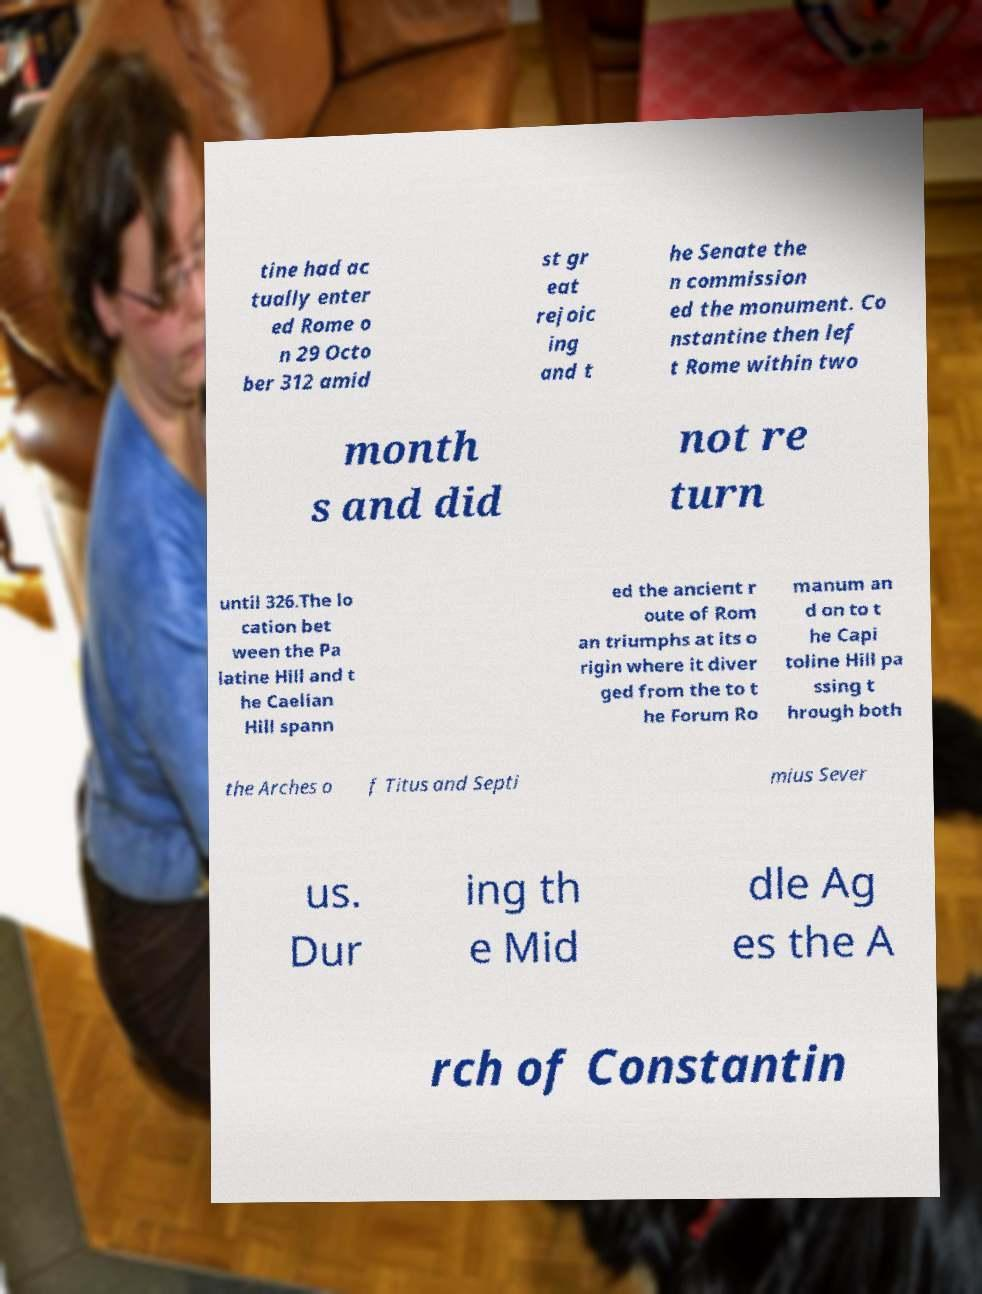Please identify and transcribe the text found in this image. tine had ac tually enter ed Rome o n 29 Octo ber 312 amid st gr eat rejoic ing and t he Senate the n commission ed the monument. Co nstantine then lef t Rome within two month s and did not re turn until 326.The lo cation bet ween the Pa latine Hill and t he Caelian Hill spann ed the ancient r oute of Rom an triumphs at its o rigin where it diver ged from the to t he Forum Ro manum an d on to t he Capi toline Hill pa ssing t hrough both the Arches o f Titus and Septi mius Sever us. Dur ing th e Mid dle Ag es the A rch of Constantin 